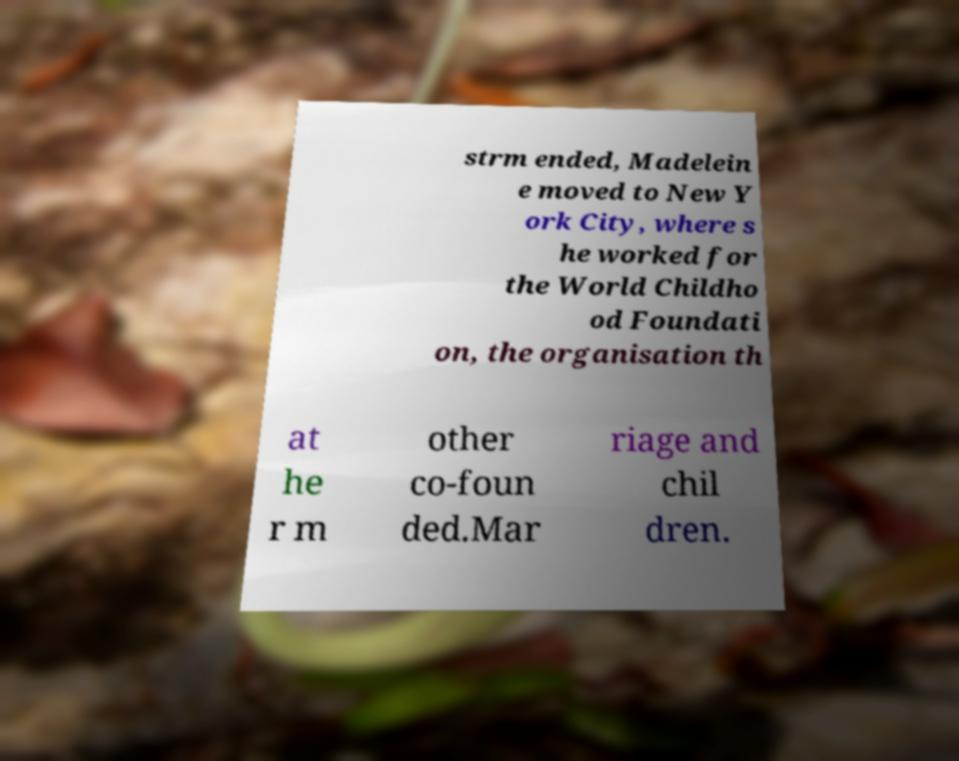There's text embedded in this image that I need extracted. Can you transcribe it verbatim? strm ended, Madelein e moved to New Y ork City, where s he worked for the World Childho od Foundati on, the organisation th at he r m other co-foun ded.Mar riage and chil dren. 